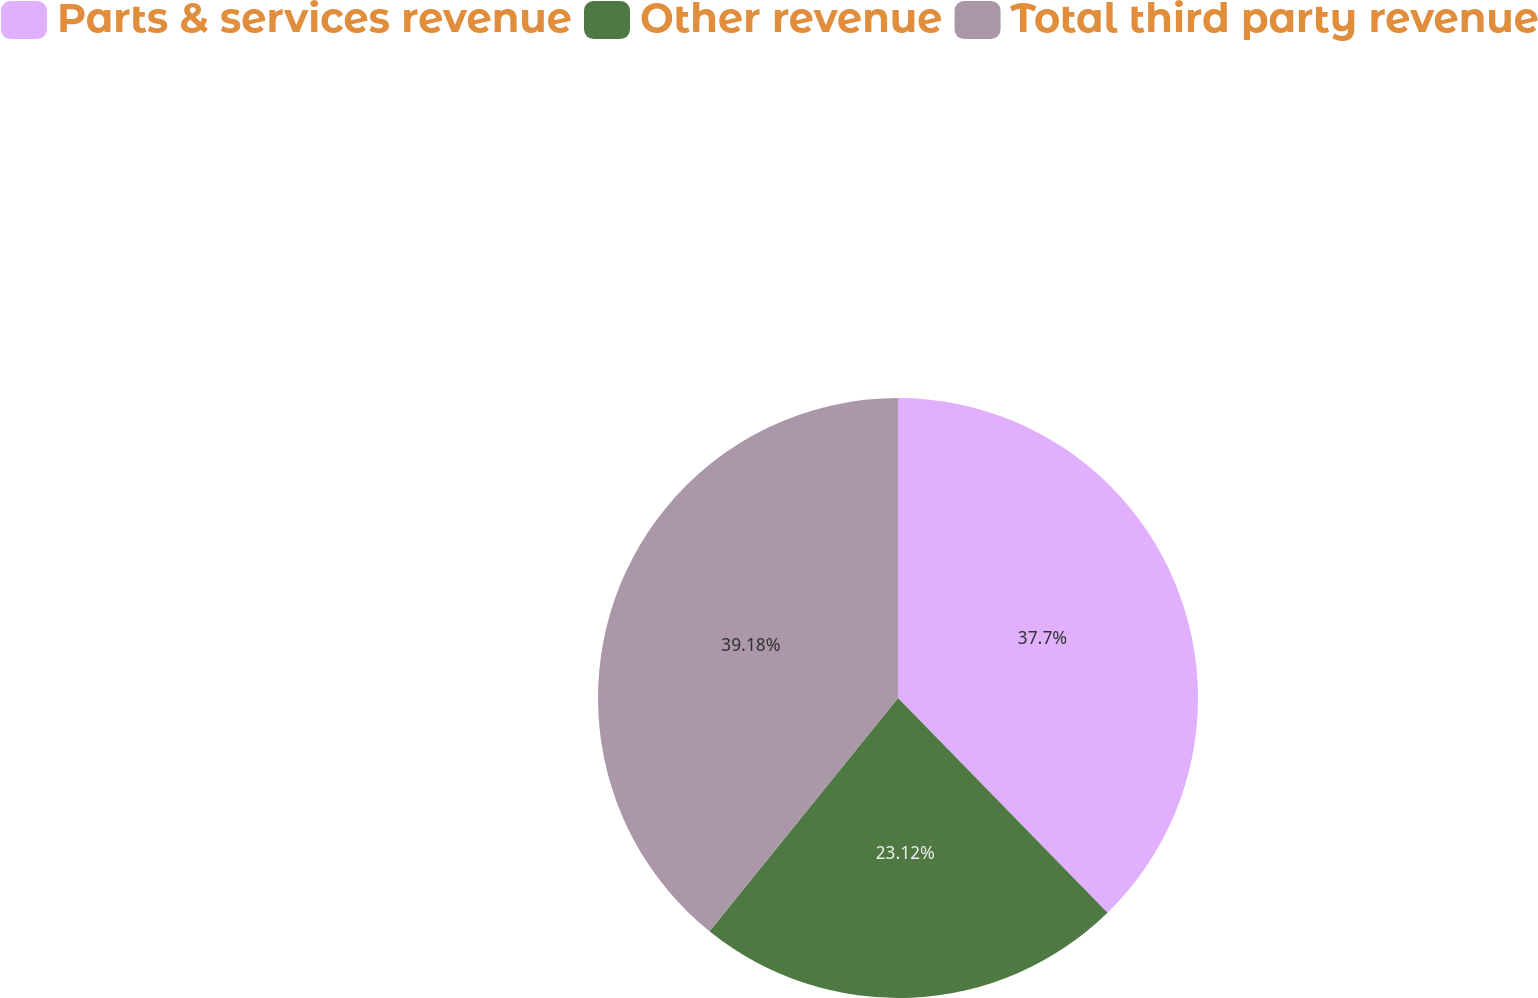Convert chart to OTSL. <chart><loc_0><loc_0><loc_500><loc_500><pie_chart><fcel>Parts & services revenue<fcel>Other revenue<fcel>Total third party revenue<nl><fcel>37.7%<fcel>23.12%<fcel>39.19%<nl></chart> 